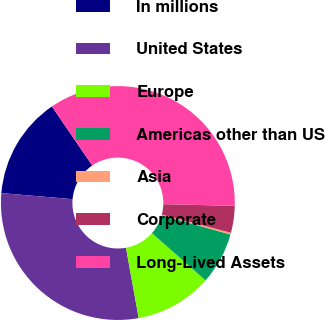Convert chart to OTSL. <chart><loc_0><loc_0><loc_500><loc_500><pie_chart><fcel>In millions<fcel>United States<fcel>Europe<fcel>Americas other than US<fcel>Asia<fcel>Corporate<fcel>Long-Lived Assets<nl><fcel>14.11%<fcel>29.21%<fcel>10.64%<fcel>7.17%<fcel>0.24%<fcel>3.71%<fcel>34.92%<nl></chart> 